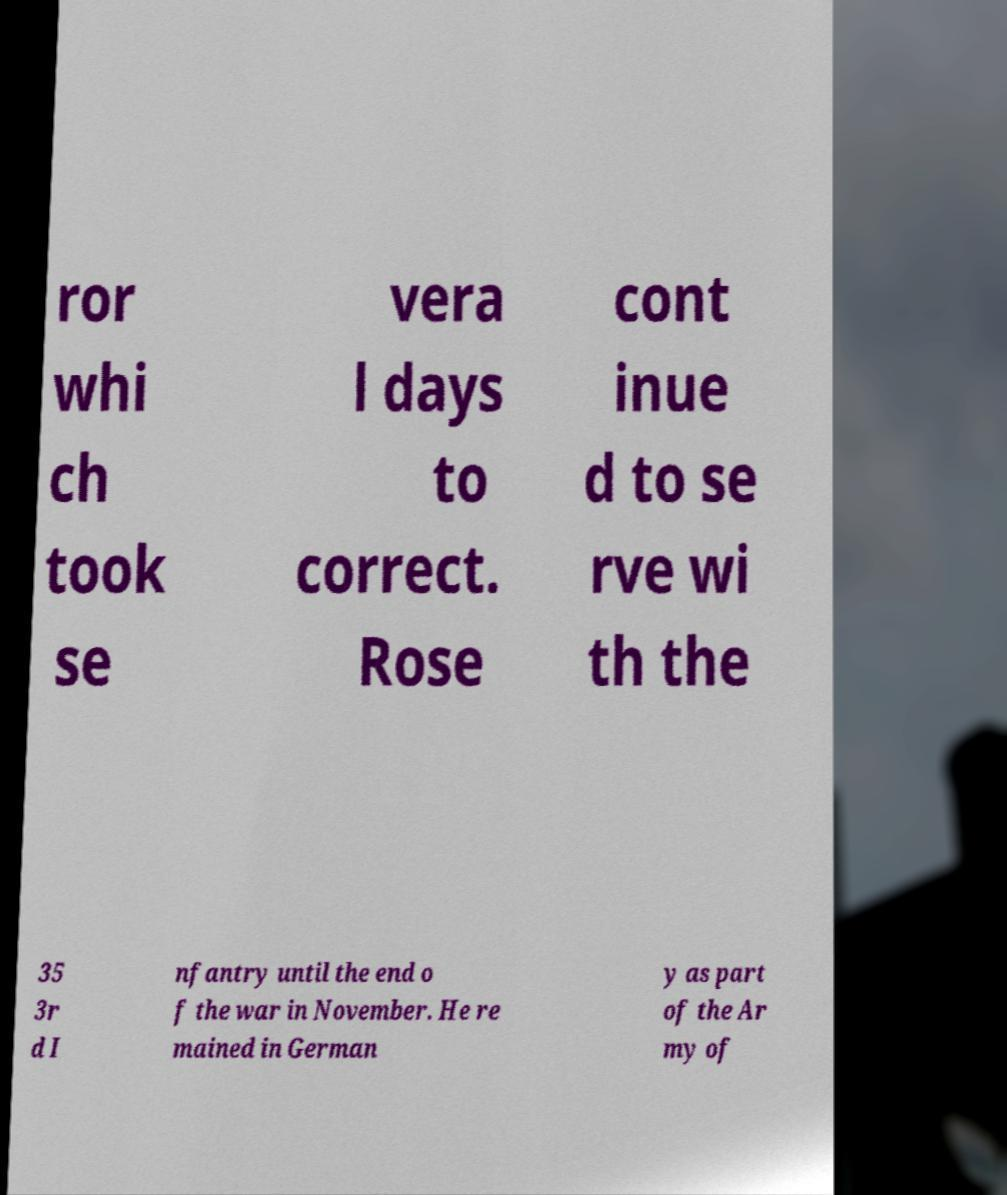Please identify and transcribe the text found in this image. ror whi ch took se vera l days to correct. Rose cont inue d to se rve wi th the 35 3r d I nfantry until the end o f the war in November. He re mained in German y as part of the Ar my of 